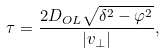<formula> <loc_0><loc_0><loc_500><loc_500>\tau = \frac { 2 D _ { O L } \sqrt { \delta ^ { 2 } - \varphi ^ { 2 } } } { | { v } _ { \perp } | } ,</formula> 